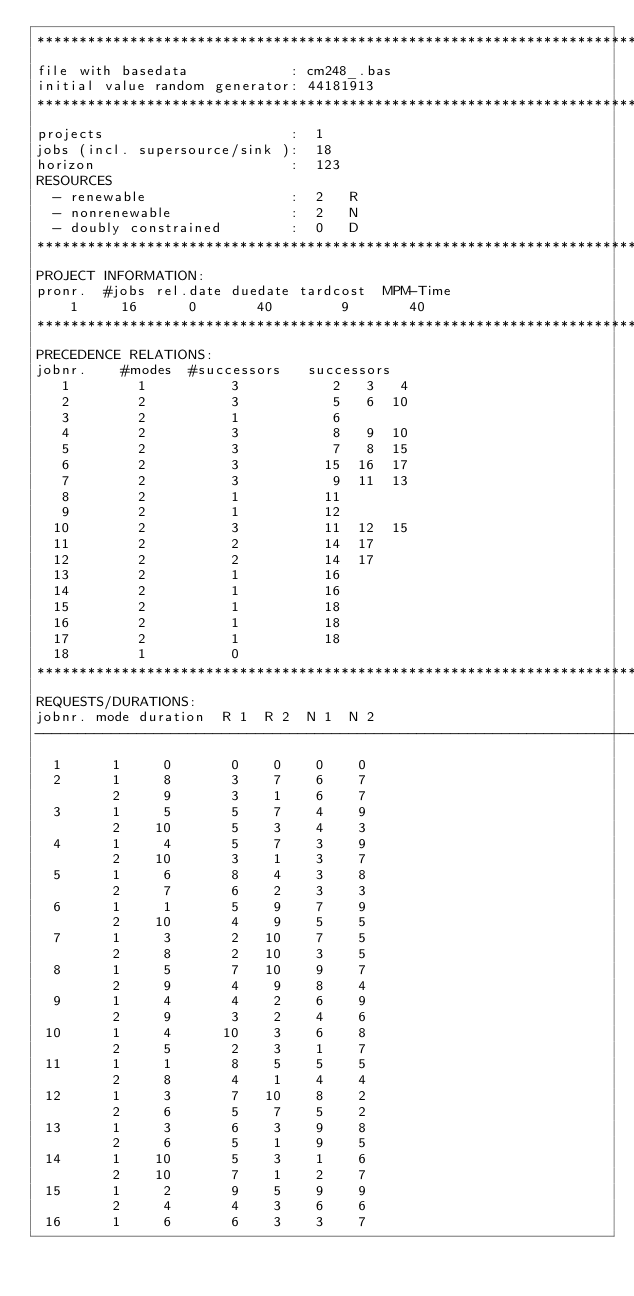Convert code to text. <code><loc_0><loc_0><loc_500><loc_500><_ObjectiveC_>************************************************************************
file with basedata            : cm248_.bas
initial value random generator: 44181913
************************************************************************
projects                      :  1
jobs (incl. supersource/sink ):  18
horizon                       :  123
RESOURCES
  - renewable                 :  2   R
  - nonrenewable              :  2   N
  - doubly constrained        :  0   D
************************************************************************
PROJECT INFORMATION:
pronr.  #jobs rel.date duedate tardcost  MPM-Time
    1     16      0       40        9       40
************************************************************************
PRECEDENCE RELATIONS:
jobnr.    #modes  #successors   successors
   1        1          3           2   3   4
   2        2          3           5   6  10
   3        2          1           6
   4        2          3           8   9  10
   5        2          3           7   8  15
   6        2          3          15  16  17
   7        2          3           9  11  13
   8        2          1          11
   9        2          1          12
  10        2          3          11  12  15
  11        2          2          14  17
  12        2          2          14  17
  13        2          1          16
  14        2          1          16
  15        2          1          18
  16        2          1          18
  17        2          1          18
  18        1          0        
************************************************************************
REQUESTS/DURATIONS:
jobnr. mode duration  R 1  R 2  N 1  N 2
------------------------------------------------------------------------
  1      1     0       0    0    0    0
  2      1     8       3    7    6    7
         2     9       3    1    6    7
  3      1     5       5    7    4    9
         2    10       5    3    4    3
  4      1     4       5    7    3    9
         2    10       3    1    3    7
  5      1     6       8    4    3    8
         2     7       6    2    3    3
  6      1     1       5    9    7    9
         2    10       4    9    5    5
  7      1     3       2   10    7    5
         2     8       2   10    3    5
  8      1     5       7   10    9    7
         2     9       4    9    8    4
  9      1     4       4    2    6    9
         2     9       3    2    4    6
 10      1     4      10    3    6    8
         2     5       2    3    1    7
 11      1     1       8    5    5    5
         2     8       4    1    4    4
 12      1     3       7   10    8    2
         2     6       5    7    5    2
 13      1     3       6    3    9    8
         2     6       5    1    9    5
 14      1    10       5    3    1    6
         2    10       7    1    2    7
 15      1     2       9    5    9    9
         2     4       4    3    6    6
 16      1     6       6    3    3    7</code> 